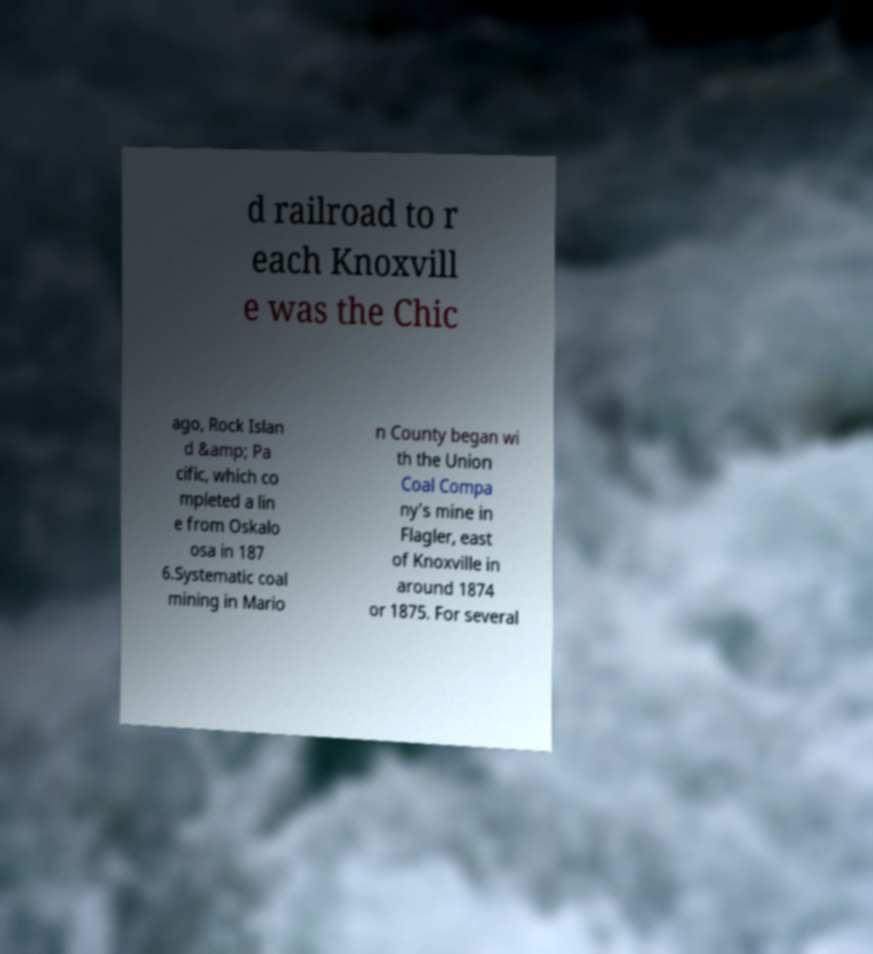Please identify and transcribe the text found in this image. d railroad to r each Knoxvill e was the Chic ago, Rock Islan d &amp; Pa cific, which co mpleted a lin e from Oskalo osa in 187 6.Systematic coal mining in Mario n County began wi th the Union Coal Compa ny's mine in Flagler, east of Knoxville in around 1874 or 1875. For several 